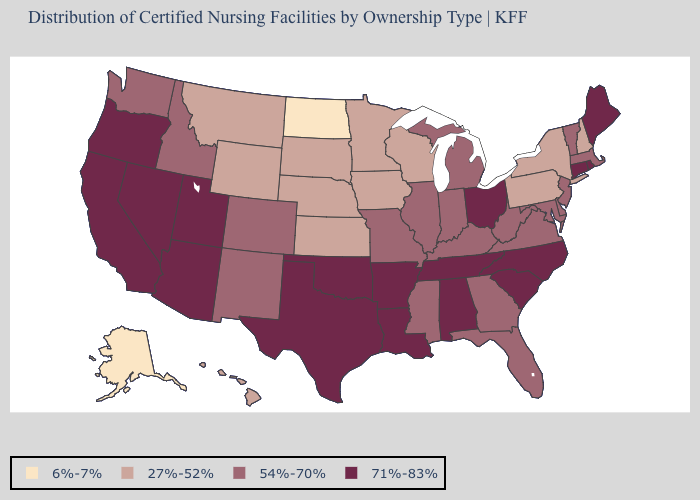How many symbols are there in the legend?
Write a very short answer. 4. Does Florida have a lower value than New Hampshire?
Give a very brief answer. No. Which states hav the highest value in the West?
Quick response, please. Arizona, California, Nevada, Oregon, Utah. What is the value of Maryland?
Answer briefly. 54%-70%. Does Oregon have the highest value in the USA?
Quick response, please. Yes. What is the lowest value in states that border Wisconsin?
Give a very brief answer. 27%-52%. Name the states that have a value in the range 71%-83%?
Be succinct. Alabama, Arizona, Arkansas, California, Connecticut, Louisiana, Maine, Nevada, North Carolina, Ohio, Oklahoma, Oregon, Rhode Island, South Carolina, Tennessee, Texas, Utah. Name the states that have a value in the range 54%-70%?
Give a very brief answer. Colorado, Delaware, Florida, Georgia, Idaho, Illinois, Indiana, Kentucky, Maryland, Massachusetts, Michigan, Mississippi, Missouri, New Jersey, New Mexico, Vermont, Virginia, Washington, West Virginia. What is the lowest value in states that border Kansas?
Write a very short answer. 27%-52%. Which states have the lowest value in the Northeast?
Give a very brief answer. New Hampshire, New York, Pennsylvania. Does Oklahoma have the lowest value in the South?
Write a very short answer. No. What is the highest value in the Northeast ?
Concise answer only. 71%-83%. Which states have the highest value in the USA?
Short answer required. Alabama, Arizona, Arkansas, California, Connecticut, Louisiana, Maine, Nevada, North Carolina, Ohio, Oklahoma, Oregon, Rhode Island, South Carolina, Tennessee, Texas, Utah. Name the states that have a value in the range 6%-7%?
Be succinct. Alaska, North Dakota. 